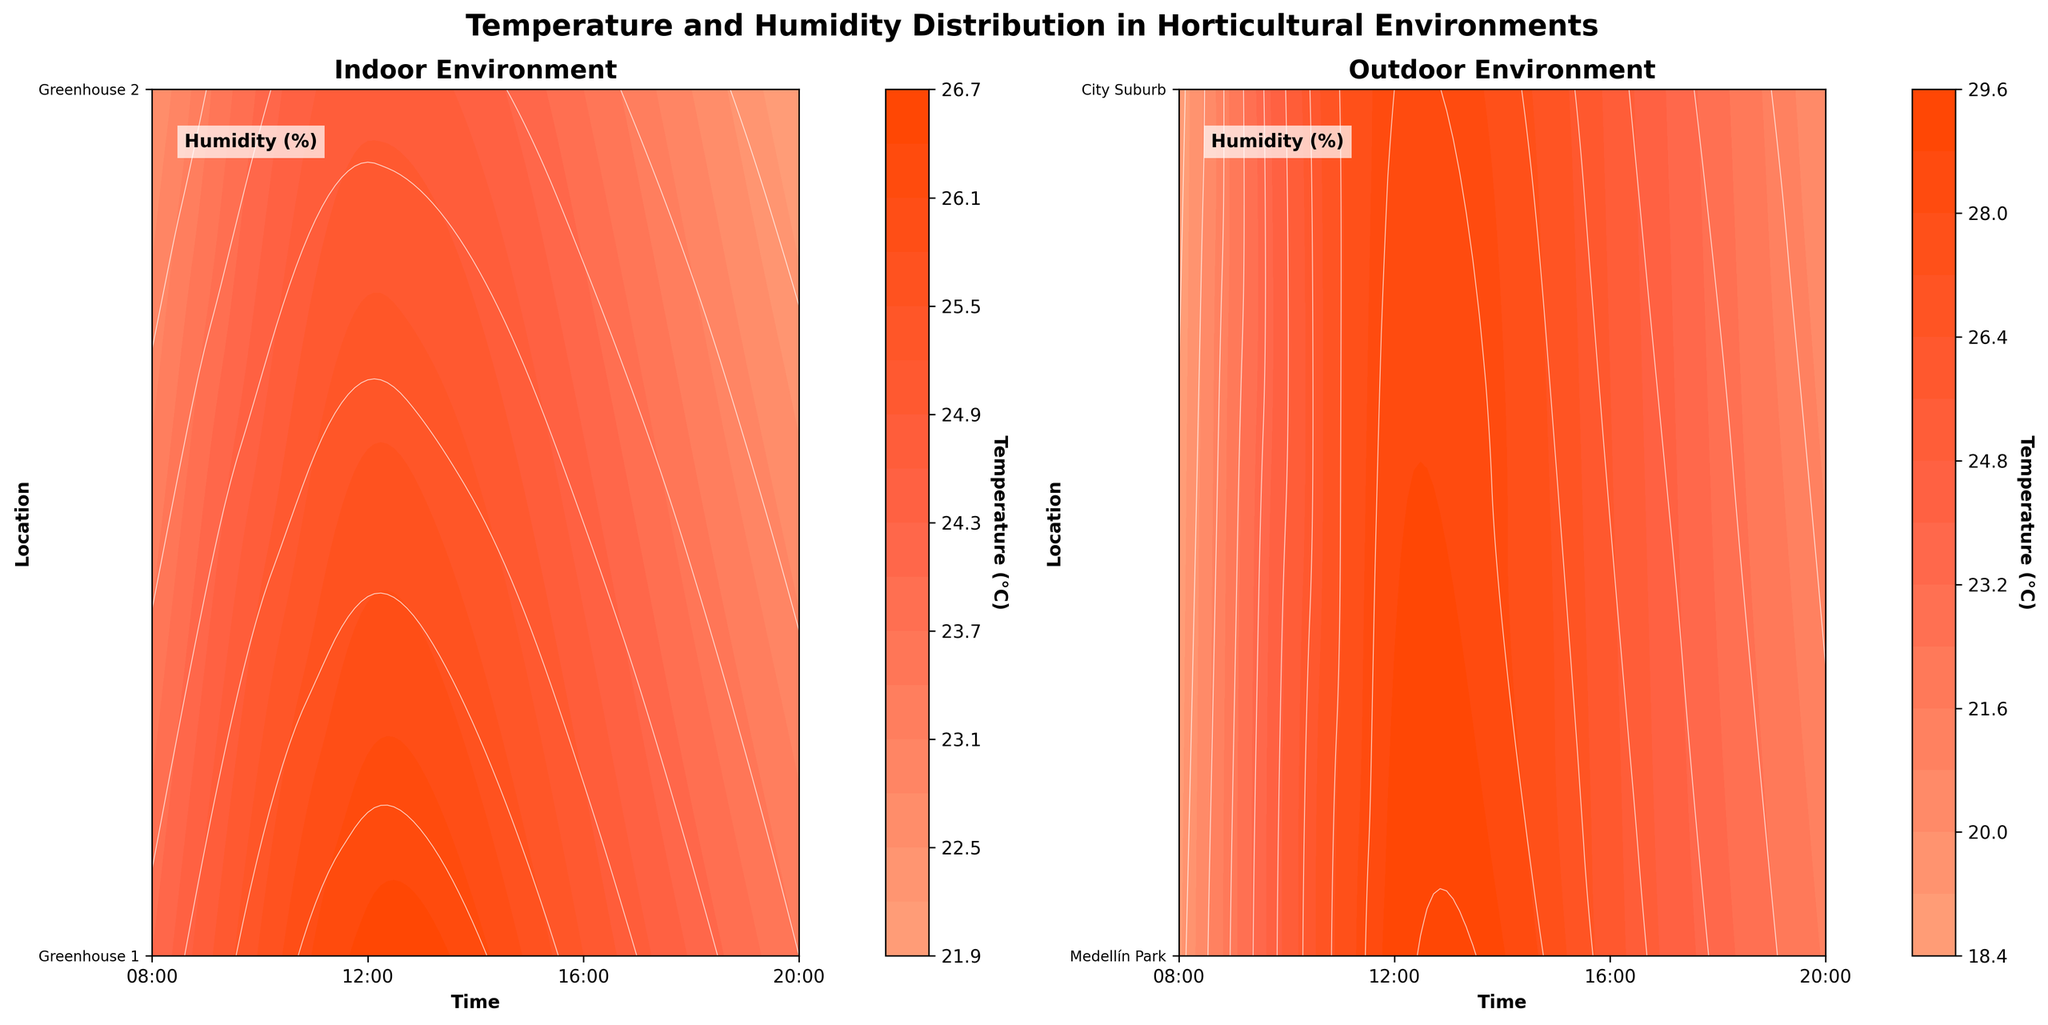What is the title of the plot? The title of the plot is displayed at the top center of the figure. It reads "Temperature and Humidity Distribution in Horticultural Environments".
Answer: Temperature and Humidity Distribution in Horticultural Environments How many subplots are there in the figure? The whole figure is divided into two side-by-side subplots.
Answer: 2 Which environment shows higher humidity levels generally? To determine this, observe the white contour lines representing humidity across both subplots. The outdoor environment generally shows higher humidity levels, which can be inferred by the placement of higher percentage lines.
Answer: Outdoor Which indoor location has the highest temperature at 12:00? Look at the contour lines in the indoor subplot around 12:00 time mark. The highest temperature at 12:00 in the indoor subplot can be identified at Greenhouse 1.
Answer: Greenhouse 1 At what time does the temperature peak in the outdoor environment? Observe the contour lines in the outdoor subplot to identify when the highest levels are reached; This usually happens around 12:00 noon.
Answer: 12:00 Which indoor location experiences the most significant drop in humidity by 20:00? Compare the contour lines for humidity at 20:00 between Greenhouse 1 and Greenhouse 2. Greenhouse 1 observes a more significant drop in humidity by 20:00.
Answer: Greenhouse 1 How does the temperature variation between 08:00 and 20:00 compare in indoor versus outdoor environments? Look at the contour lines marking temperature changes from 08:00 to 20:00 in both subplots. The outdoor environment shows a higher variation compared to the indoor environment.
Answer: Outdoor has a higher variation Is the temperature more stable in Greenhouse 1 or Medellín Park? Check the smoothness and range of the contour lines representing temperature in these two locations. Greenhouse 1 displays a more stable temperature as compared to Medellín Park.
Answer: Greenhouse 1 In terms of humidity, which location shows the least variation throughout the day? Study the contours representing humidity changes over time. The City Suburb in the outdoor environment experiences relatively less variation in humidity.
Answer: City Suburb Does Greenhouse 2 ever reach the same maximum temperature observed in Medellín Park? Compare the maximum temperature values indicated by the contour lines in both Greenhouse 2 and Medellín Park. Greenhouse 2 does not reach the maximum temperature observed in Medellín Park.
Answer: No 